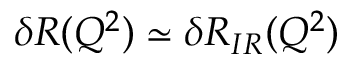Convert formula to latex. <formula><loc_0><loc_0><loc_500><loc_500>\delta R ( Q ^ { 2 } ) \simeq \delta R _ { I R } ( Q ^ { 2 } )</formula> 